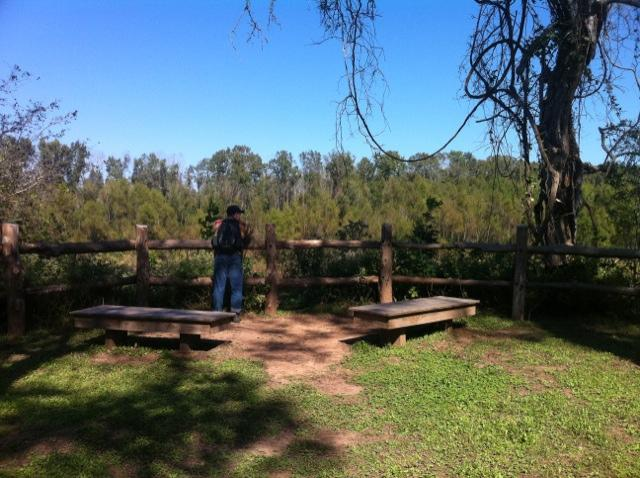What is the person leaning against?

Choices:
A) fence
B) cross
C) horse
D) egg fence 